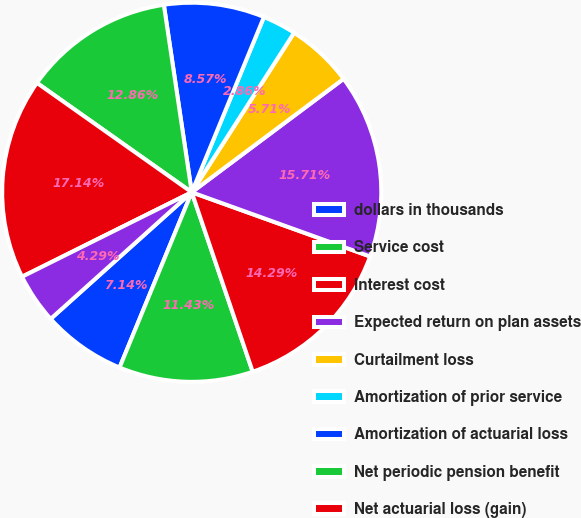Convert chart. <chart><loc_0><loc_0><loc_500><loc_500><pie_chart><fcel>dollars in thousands<fcel>Service cost<fcel>Interest cost<fcel>Expected return on plan assets<fcel>Curtailment loss<fcel>Amortization of prior service<fcel>Amortization of actuarial loss<fcel>Net periodic pension benefit<fcel>Net actuarial loss (gain)<fcel>Prior service cost (credit)<nl><fcel>7.14%<fcel>11.43%<fcel>14.29%<fcel>15.71%<fcel>5.71%<fcel>2.86%<fcel>8.57%<fcel>12.86%<fcel>17.14%<fcel>4.29%<nl></chart> 